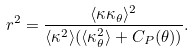<formula> <loc_0><loc_0><loc_500><loc_500>r ^ { 2 } = \frac { \langle \kappa \kappa _ { \theta } \rangle ^ { 2 } } { \langle \kappa ^ { 2 } \rangle ( \langle \kappa _ { \theta } ^ { 2 } \rangle + C _ { P } ( \theta ) ) } .</formula> 